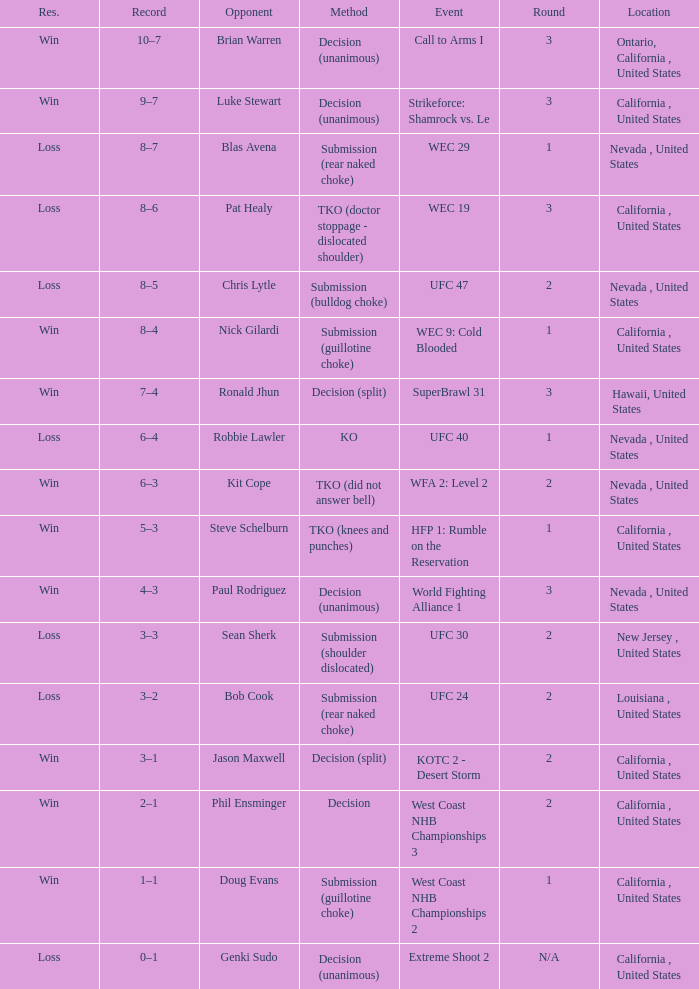What is the final result for the call to arms i event? Win. 